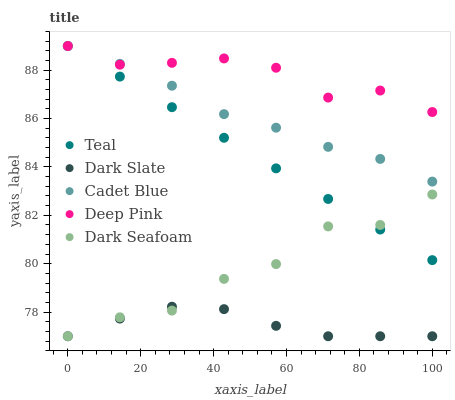Does Dark Slate have the minimum area under the curve?
Answer yes or no. Yes. Does Deep Pink have the maximum area under the curve?
Answer yes or no. Yes. Does Dark Seafoam have the minimum area under the curve?
Answer yes or no. No. Does Dark Seafoam have the maximum area under the curve?
Answer yes or no. No. Is Teal the smoothest?
Answer yes or no. Yes. Is Dark Seafoam the roughest?
Answer yes or no. Yes. Is Cadet Blue the smoothest?
Answer yes or no. No. Is Cadet Blue the roughest?
Answer yes or no. No. Does Dark Slate have the lowest value?
Answer yes or no. Yes. Does Cadet Blue have the lowest value?
Answer yes or no. No. Does Deep Pink have the highest value?
Answer yes or no. Yes. Does Dark Seafoam have the highest value?
Answer yes or no. No. Is Dark Seafoam less than Deep Pink?
Answer yes or no. Yes. Is Deep Pink greater than Dark Seafoam?
Answer yes or no. Yes. Does Dark Slate intersect Dark Seafoam?
Answer yes or no. Yes. Is Dark Slate less than Dark Seafoam?
Answer yes or no. No. Is Dark Slate greater than Dark Seafoam?
Answer yes or no. No. Does Dark Seafoam intersect Deep Pink?
Answer yes or no. No. 